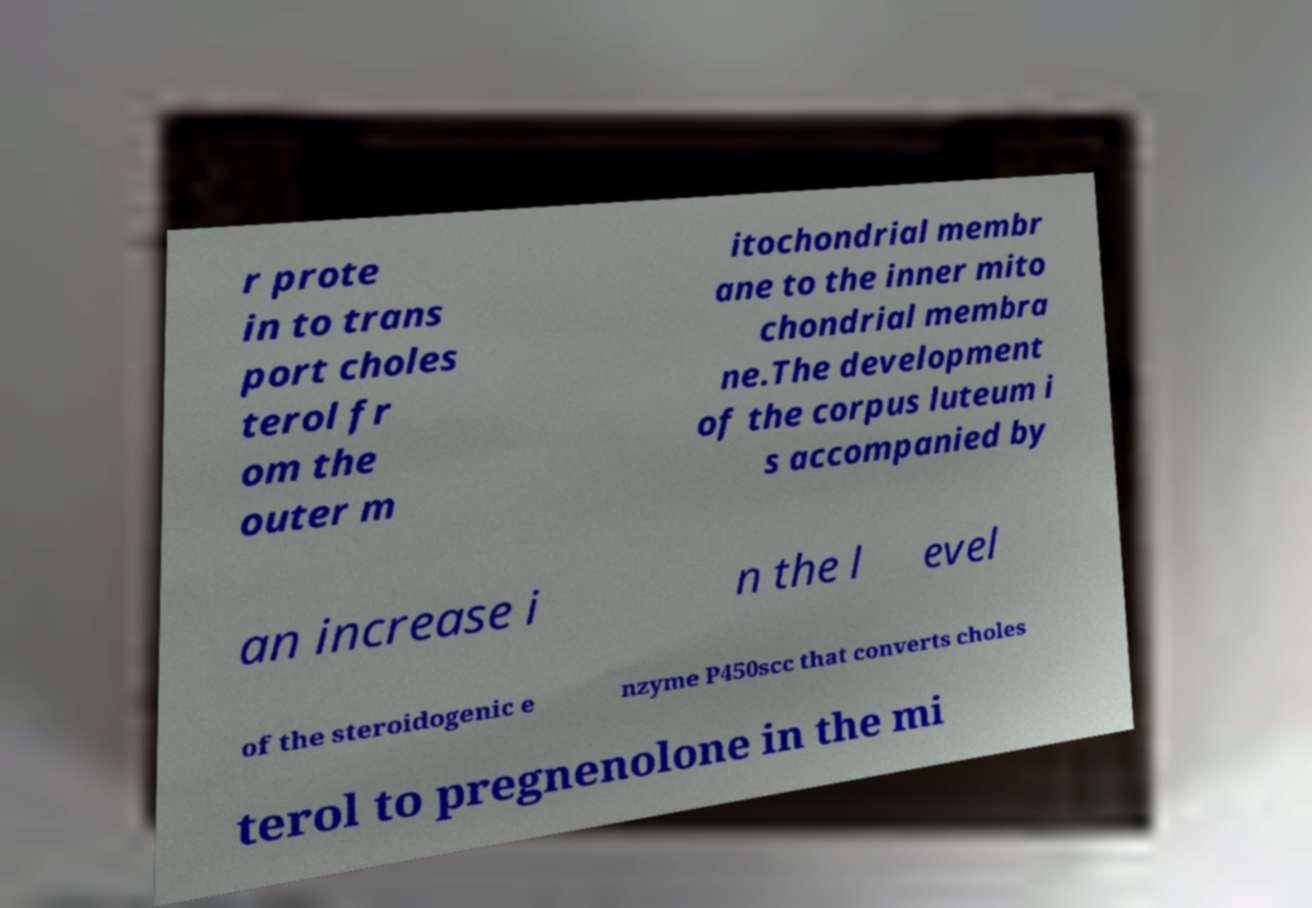Could you assist in decoding the text presented in this image and type it out clearly? r prote in to trans port choles terol fr om the outer m itochondrial membr ane to the inner mito chondrial membra ne.The development of the corpus luteum i s accompanied by an increase i n the l evel of the steroidogenic e nzyme P450scc that converts choles terol to pregnenolone in the mi 